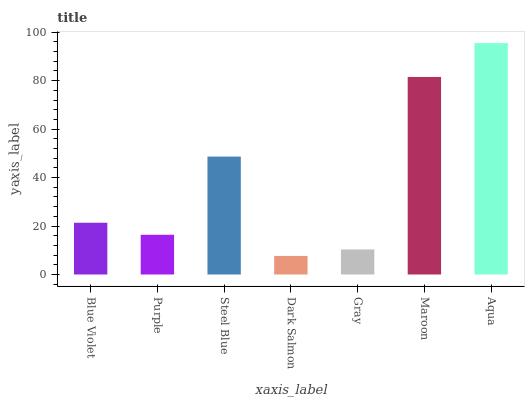Is Dark Salmon the minimum?
Answer yes or no. Yes. Is Aqua the maximum?
Answer yes or no. Yes. Is Purple the minimum?
Answer yes or no. No. Is Purple the maximum?
Answer yes or no. No. Is Blue Violet greater than Purple?
Answer yes or no. Yes. Is Purple less than Blue Violet?
Answer yes or no. Yes. Is Purple greater than Blue Violet?
Answer yes or no. No. Is Blue Violet less than Purple?
Answer yes or no. No. Is Blue Violet the high median?
Answer yes or no. Yes. Is Blue Violet the low median?
Answer yes or no. Yes. Is Gray the high median?
Answer yes or no. No. Is Dark Salmon the low median?
Answer yes or no. No. 